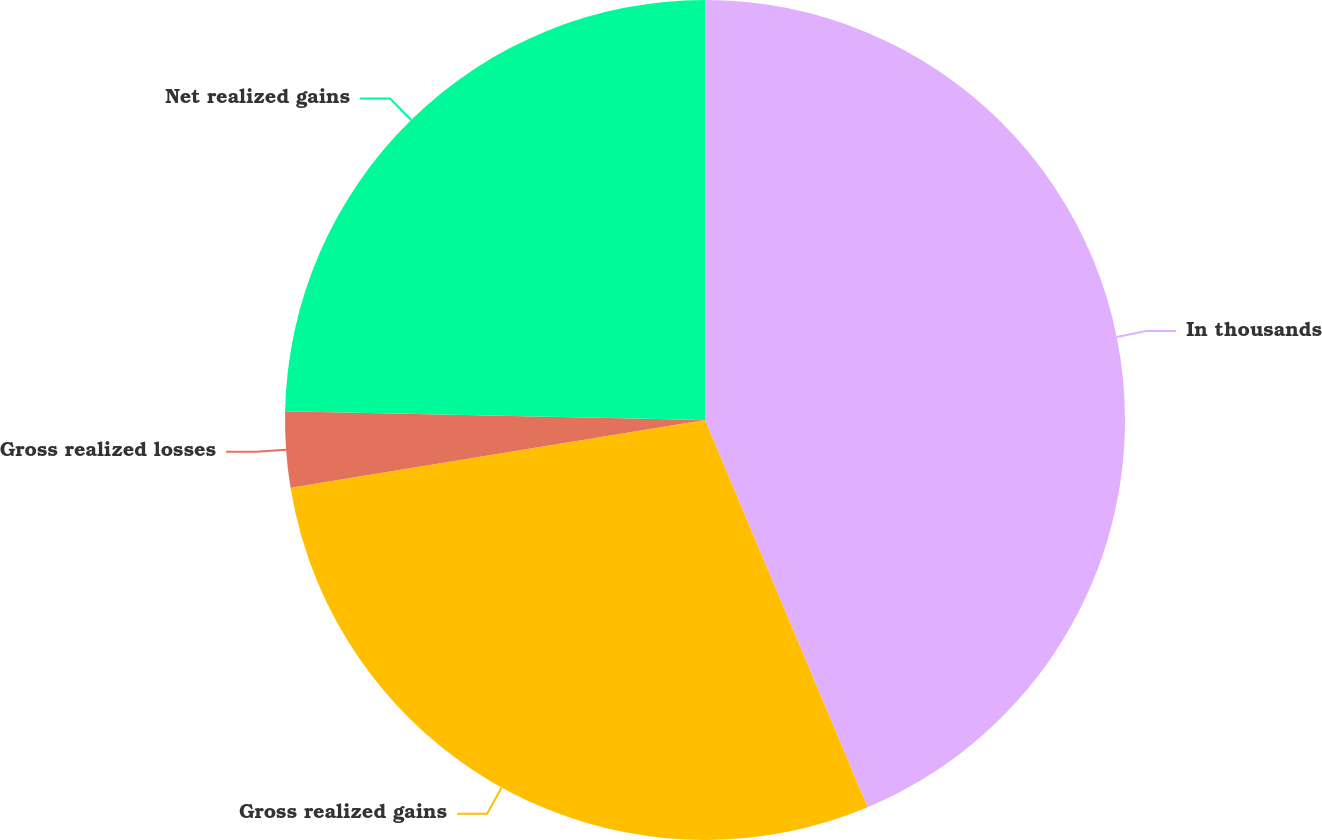<chart> <loc_0><loc_0><loc_500><loc_500><pie_chart><fcel>In thousands<fcel>Gross realized gains<fcel>Gross realized losses<fcel>Net realized gains<nl><fcel>43.67%<fcel>28.75%<fcel>2.91%<fcel>24.67%<nl></chart> 